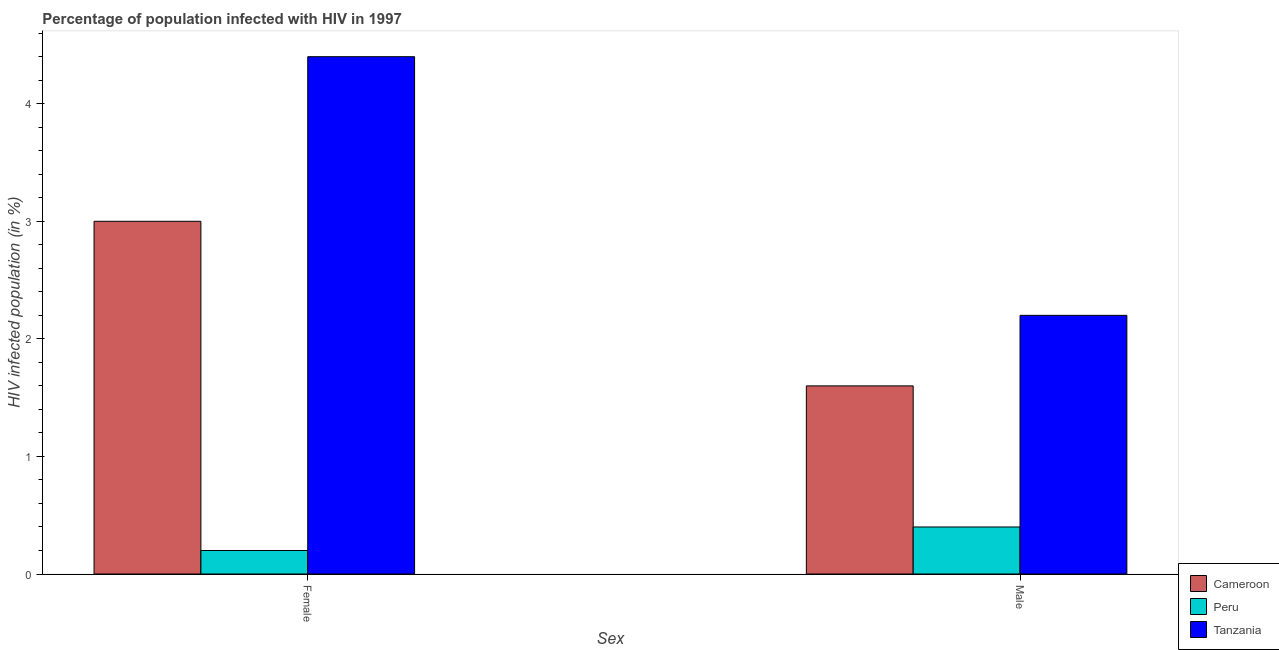How many different coloured bars are there?
Your response must be concise. 3. How many groups of bars are there?
Ensure brevity in your answer.  2. Are the number of bars on each tick of the X-axis equal?
Ensure brevity in your answer.  Yes. How many bars are there on the 1st tick from the left?
Provide a succinct answer. 3. What is the percentage of males who are infected with hiv in Peru?
Your answer should be compact. 0.4. Across all countries, what is the maximum percentage of females who are infected with hiv?
Make the answer very short. 4.4. In which country was the percentage of females who are infected with hiv maximum?
Provide a short and direct response. Tanzania. In which country was the percentage of males who are infected with hiv minimum?
Keep it short and to the point. Peru. What is the total percentage of males who are infected with hiv in the graph?
Offer a very short reply. 4.2. What is the difference between the percentage of females who are infected with hiv in Tanzania and that in Cameroon?
Provide a succinct answer. 1.4. What is the average percentage of females who are infected with hiv per country?
Make the answer very short. 2.53. In how many countries, is the percentage of females who are infected with hiv greater than 2.8 %?
Provide a succinct answer. 2. What is the ratio of the percentage of males who are infected with hiv in Cameroon to that in Tanzania?
Your answer should be very brief. 0.73. Is the percentage of females who are infected with hiv in Tanzania less than that in Cameroon?
Provide a short and direct response. No. What does the 3rd bar from the left in Female represents?
Your response must be concise. Tanzania. What does the 3rd bar from the right in Female represents?
Your response must be concise. Cameroon. Are all the bars in the graph horizontal?
Make the answer very short. No. Does the graph contain any zero values?
Your answer should be compact. No. Does the graph contain grids?
Give a very brief answer. No. Where does the legend appear in the graph?
Ensure brevity in your answer.  Bottom right. How many legend labels are there?
Give a very brief answer. 3. What is the title of the graph?
Give a very brief answer. Percentage of population infected with HIV in 1997. Does "Zimbabwe" appear as one of the legend labels in the graph?
Your answer should be compact. No. What is the label or title of the X-axis?
Make the answer very short. Sex. What is the label or title of the Y-axis?
Your answer should be compact. HIV infected population (in %). What is the HIV infected population (in %) in Cameroon in Female?
Your response must be concise. 3. What is the HIV infected population (in %) of Peru in Female?
Your answer should be compact. 0.2. What is the HIV infected population (in %) in Peru in Male?
Provide a short and direct response. 0.4. Across all Sex, what is the minimum HIV infected population (in %) in Cameroon?
Offer a terse response. 1.6. What is the total HIV infected population (in %) in Peru in the graph?
Offer a terse response. 0.6. What is the difference between the HIV infected population (in %) in Cameroon in Female and that in Male?
Make the answer very short. 1.4. What is the difference between the HIV infected population (in %) of Tanzania in Female and that in Male?
Your answer should be compact. 2.2. What is the difference between the HIV infected population (in %) in Cameroon in Female and the HIV infected population (in %) in Peru in Male?
Offer a very short reply. 2.6. What is the average HIV infected population (in %) of Peru per Sex?
Provide a short and direct response. 0.3. What is the average HIV infected population (in %) of Tanzania per Sex?
Provide a short and direct response. 3.3. What is the difference between the HIV infected population (in %) in Cameroon and HIV infected population (in %) in Tanzania in Female?
Keep it short and to the point. -1.4. What is the difference between the HIV infected population (in %) of Cameroon and HIV infected population (in %) of Peru in Male?
Keep it short and to the point. 1.2. What is the ratio of the HIV infected population (in %) of Cameroon in Female to that in Male?
Provide a short and direct response. 1.88. What is the ratio of the HIV infected population (in %) of Tanzania in Female to that in Male?
Offer a terse response. 2. What is the difference between the highest and the second highest HIV infected population (in %) in Cameroon?
Your answer should be very brief. 1.4. What is the difference between the highest and the second highest HIV infected population (in %) in Peru?
Your response must be concise. 0.2. What is the difference between the highest and the second highest HIV infected population (in %) of Tanzania?
Offer a very short reply. 2.2. What is the difference between the highest and the lowest HIV infected population (in %) in Cameroon?
Ensure brevity in your answer.  1.4. What is the difference between the highest and the lowest HIV infected population (in %) in Peru?
Offer a terse response. 0.2. 